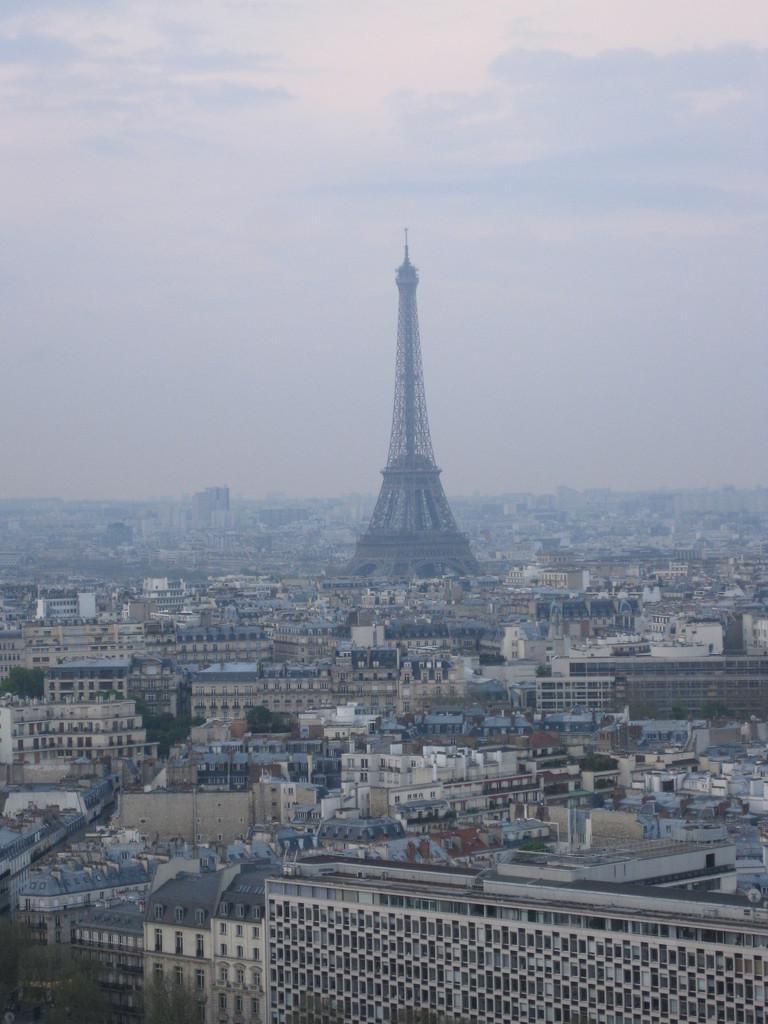Describe this image in one or two sentences. This is an overview of a city, we can see buildings and a tower at the bottom of this image, and there is a sky in the background. 